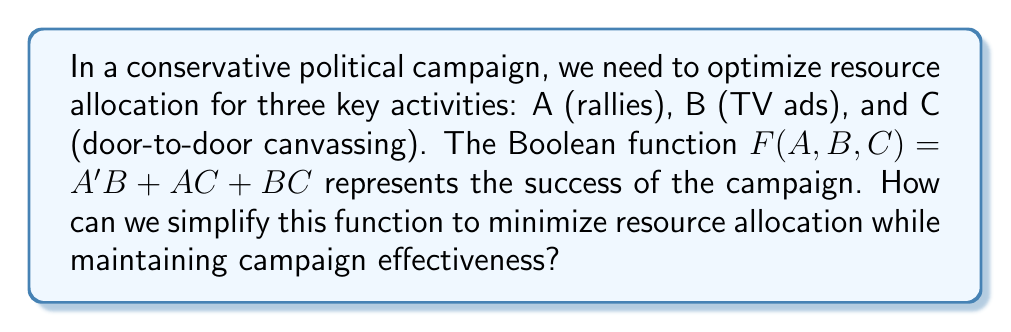Teach me how to tackle this problem. Let's simplify the Boolean function $F(A,B,C) = A'B + AC + BC$ step by step:

1) First, we can use the distributive law to factor out B:
   $F(A,B,C) = A'B + AC + BC = B(A' + C) + AC$

2) Now, let's focus on the term $(A' + C)$. We can use the absorption law:
   $A' + C = A' + C + AC$ (adding AC doesn't change the result)

3) Substituting this back into our function:
   $F(A,B,C) = B(A' + C + AC) + AC$

4) Distributing B:
   $F(A,B,C) = BA' + BC + BAC + AC$

5) We can combine BC and BAC using the absorption law:
   $BC + BAC = BC$

6) Our function is now:
   $F(A,B,C) = BA' + BC + AC$

7) This is our final simplified form. It shows that we need to allocate resources to either:
   - Rallies (A) AND TV ads (B), OR
   - TV ads (B) AND door-to-door canvassing (C), OR
   - Rallies (A) AND door-to-door canvassing (C)

This optimization suggests that we always need to combine two activities for an effective campaign, but we don't need to do all three simultaneously.
Answer: $F(A,B,C) = BA' + BC + AC$ 